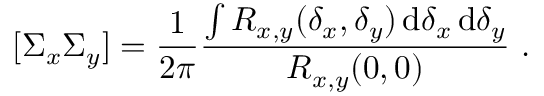Convert formula to latex. <formula><loc_0><loc_0><loc_500><loc_500>[ \Sigma _ { x } \Sigma _ { y } ] = \frac { 1 } { 2 \pi } \frac { { \int { R _ { x , y } ( \delta _ { x } , \delta _ { y } ) \, d \delta _ { x } \, d \delta _ { y } } } } { { R _ { x , y } ( 0 , 0 ) } } .</formula> 